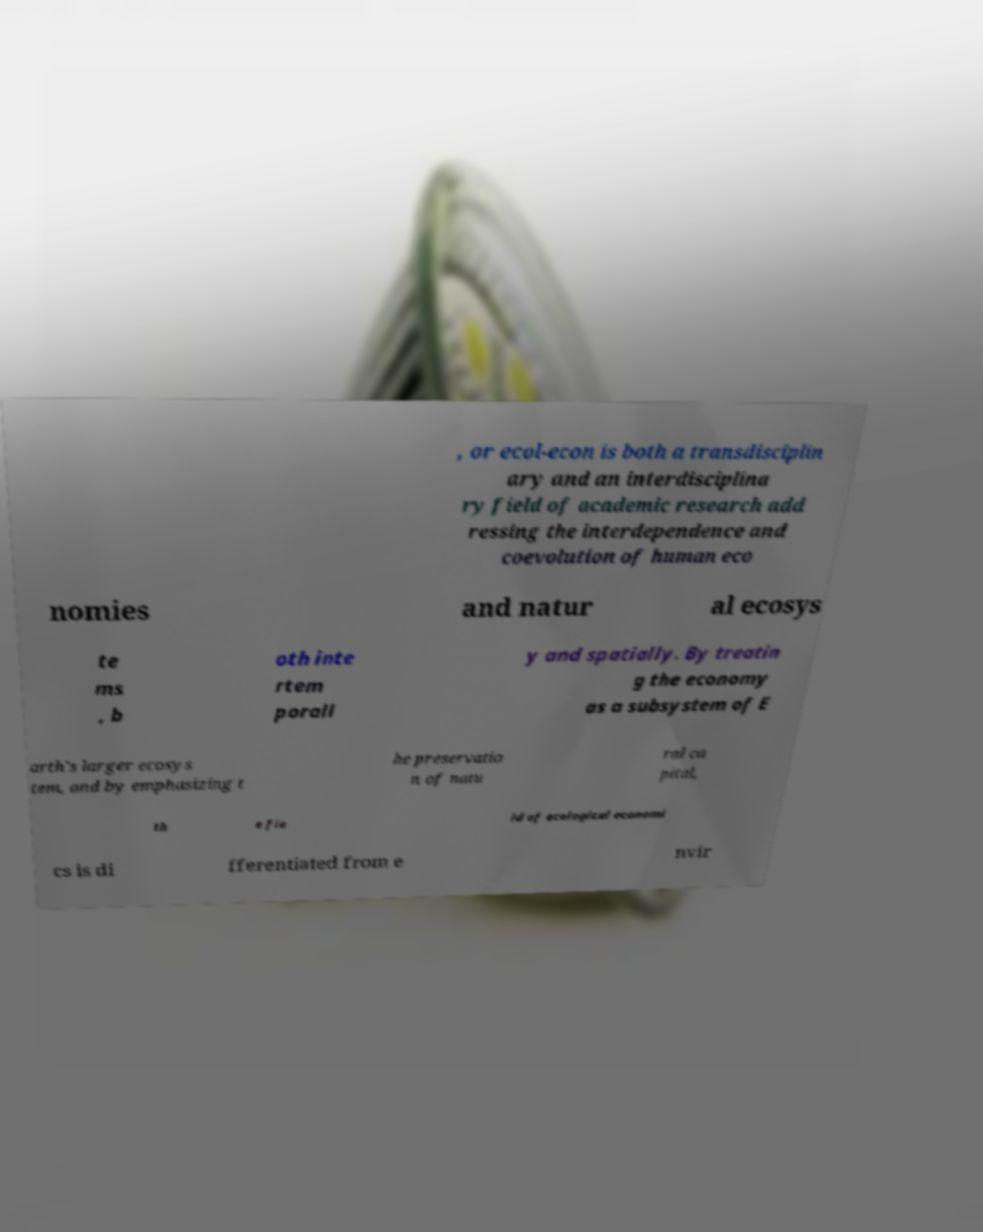Can you accurately transcribe the text from the provided image for me? , or ecol-econ is both a transdisciplin ary and an interdisciplina ry field of academic research add ressing the interdependence and coevolution of human eco nomies and natur al ecosys te ms , b oth inte rtem porall y and spatially. By treatin g the economy as a subsystem of E arth's larger ecosys tem, and by emphasizing t he preservatio n of natu ral ca pital, th e fie ld of ecological economi cs is di fferentiated from e nvir 